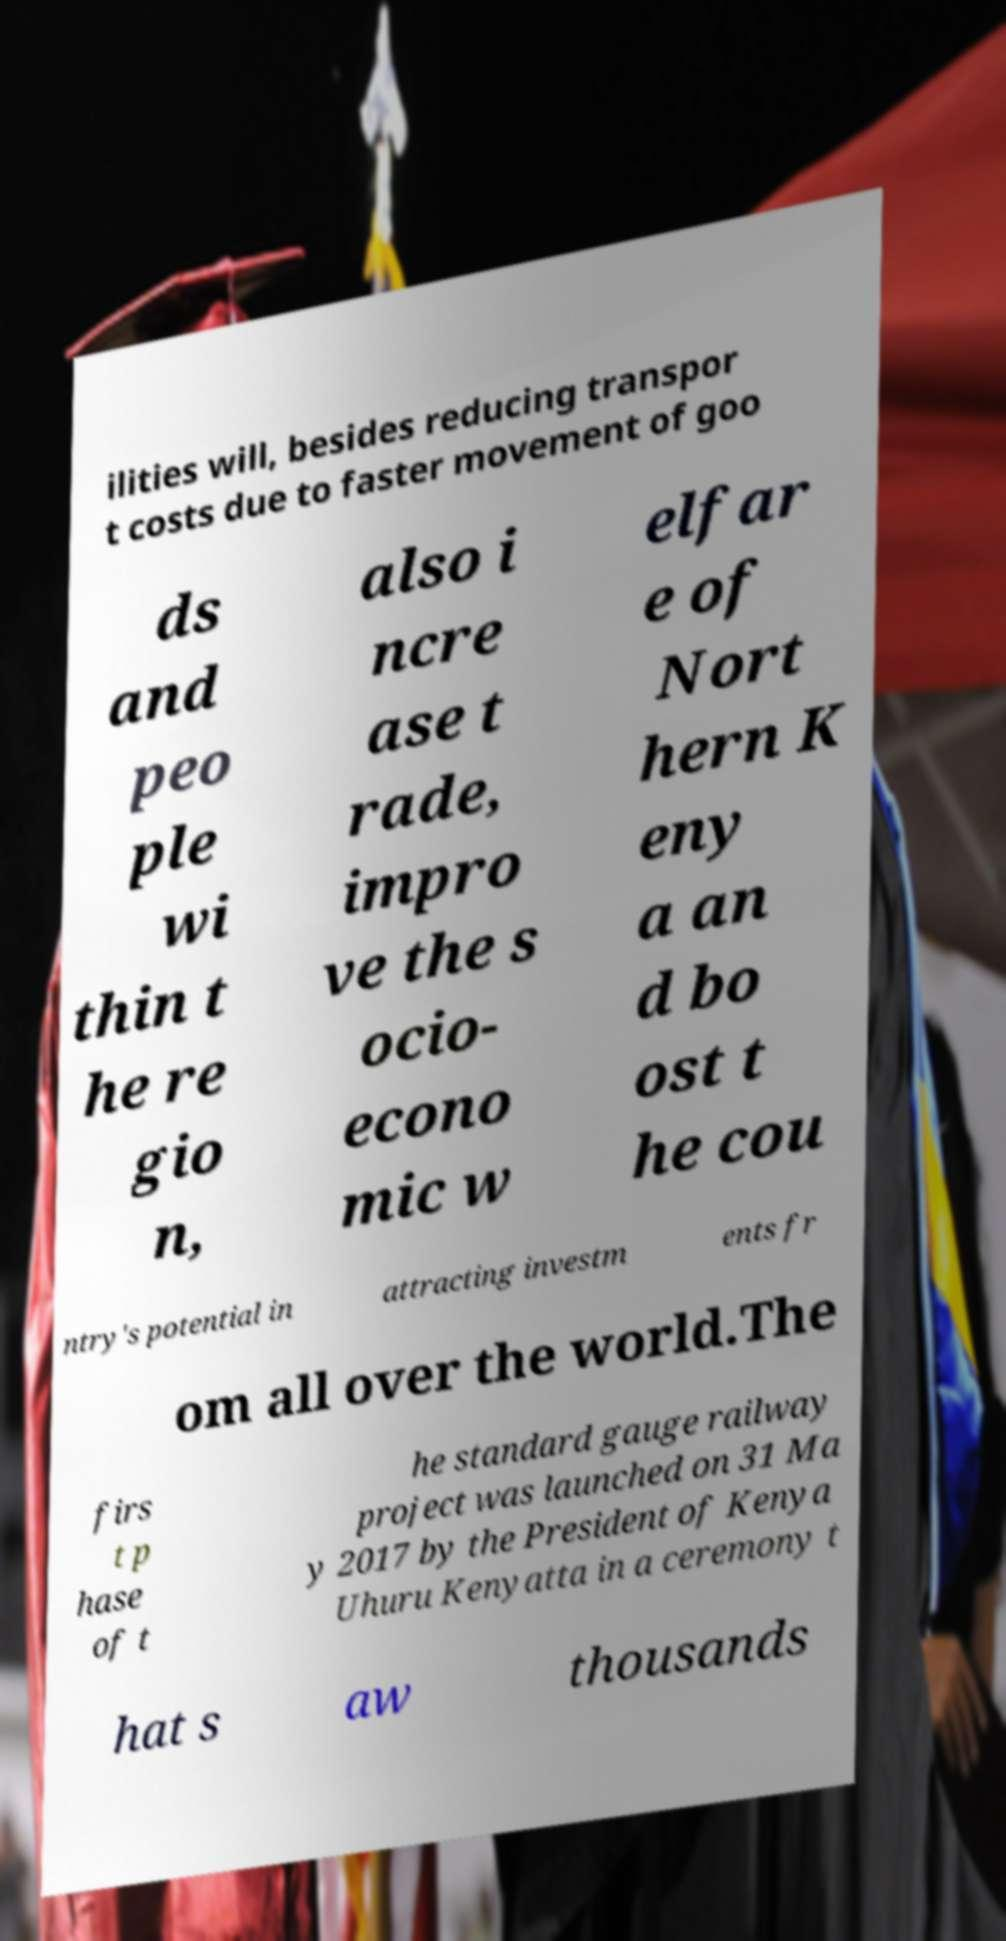Could you assist in decoding the text presented in this image and type it out clearly? ilities will, besides reducing transpor t costs due to faster movement of goo ds and peo ple wi thin t he re gio n, also i ncre ase t rade, impro ve the s ocio- econo mic w elfar e of Nort hern K eny a an d bo ost t he cou ntry's potential in attracting investm ents fr om all over the world.The firs t p hase of t he standard gauge railway project was launched on 31 Ma y 2017 by the President of Kenya Uhuru Kenyatta in a ceremony t hat s aw thousands 